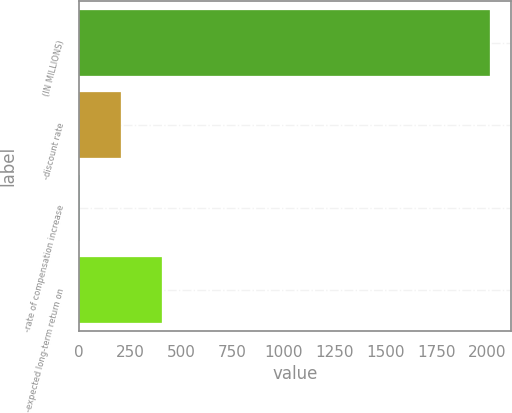Convert chart. <chart><loc_0><loc_0><loc_500><loc_500><bar_chart><fcel>(IN MILLIONS)<fcel>-discount rate<fcel>-rate of compensation increase<fcel>-expected long-term return on<nl><fcel>2013<fcel>203.19<fcel>2.1<fcel>404.28<nl></chart> 